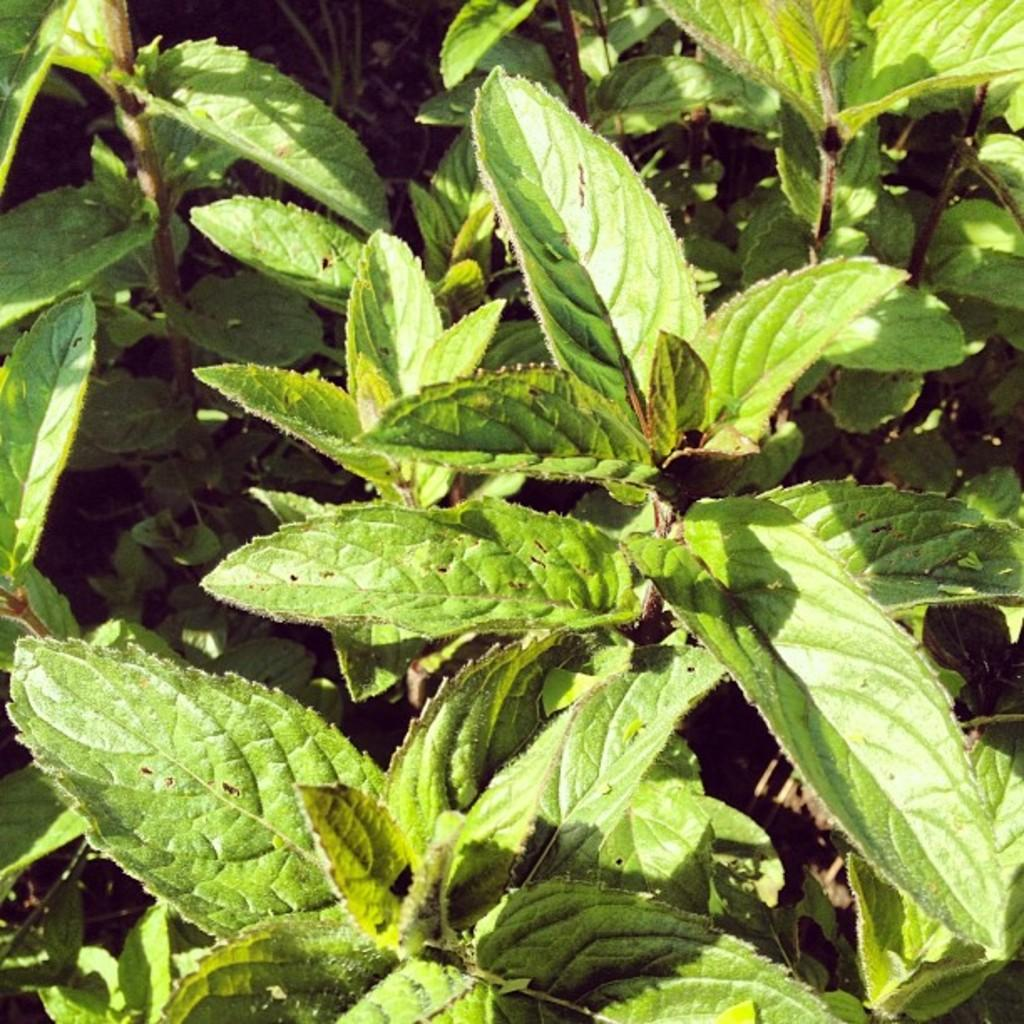What type of living organisms can be seen in the image? Plants can be seen in the image. Can you tell me the expert opinion on the taste of the plants in the image? There is no expert opinion on the taste of the plants in the image, as taste is not a characteristic that can be determined from a visual representation. 